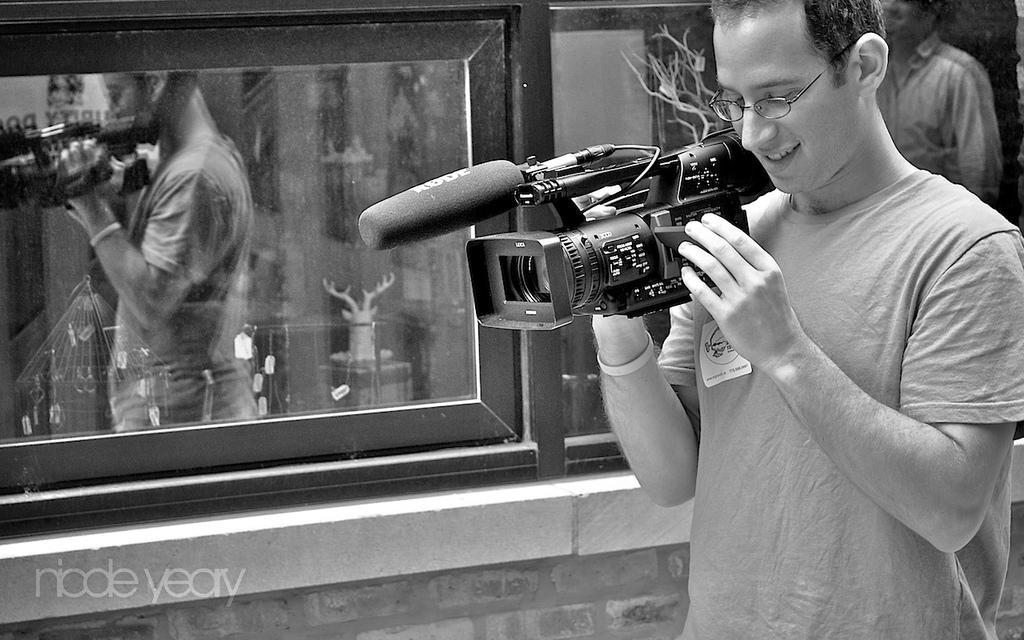Describe this image in one or two sentences. In this image. On the right there is a man he wear t shirt he is smiling he hold a camera, i think he is recording something. In the background there is a window and a person. 